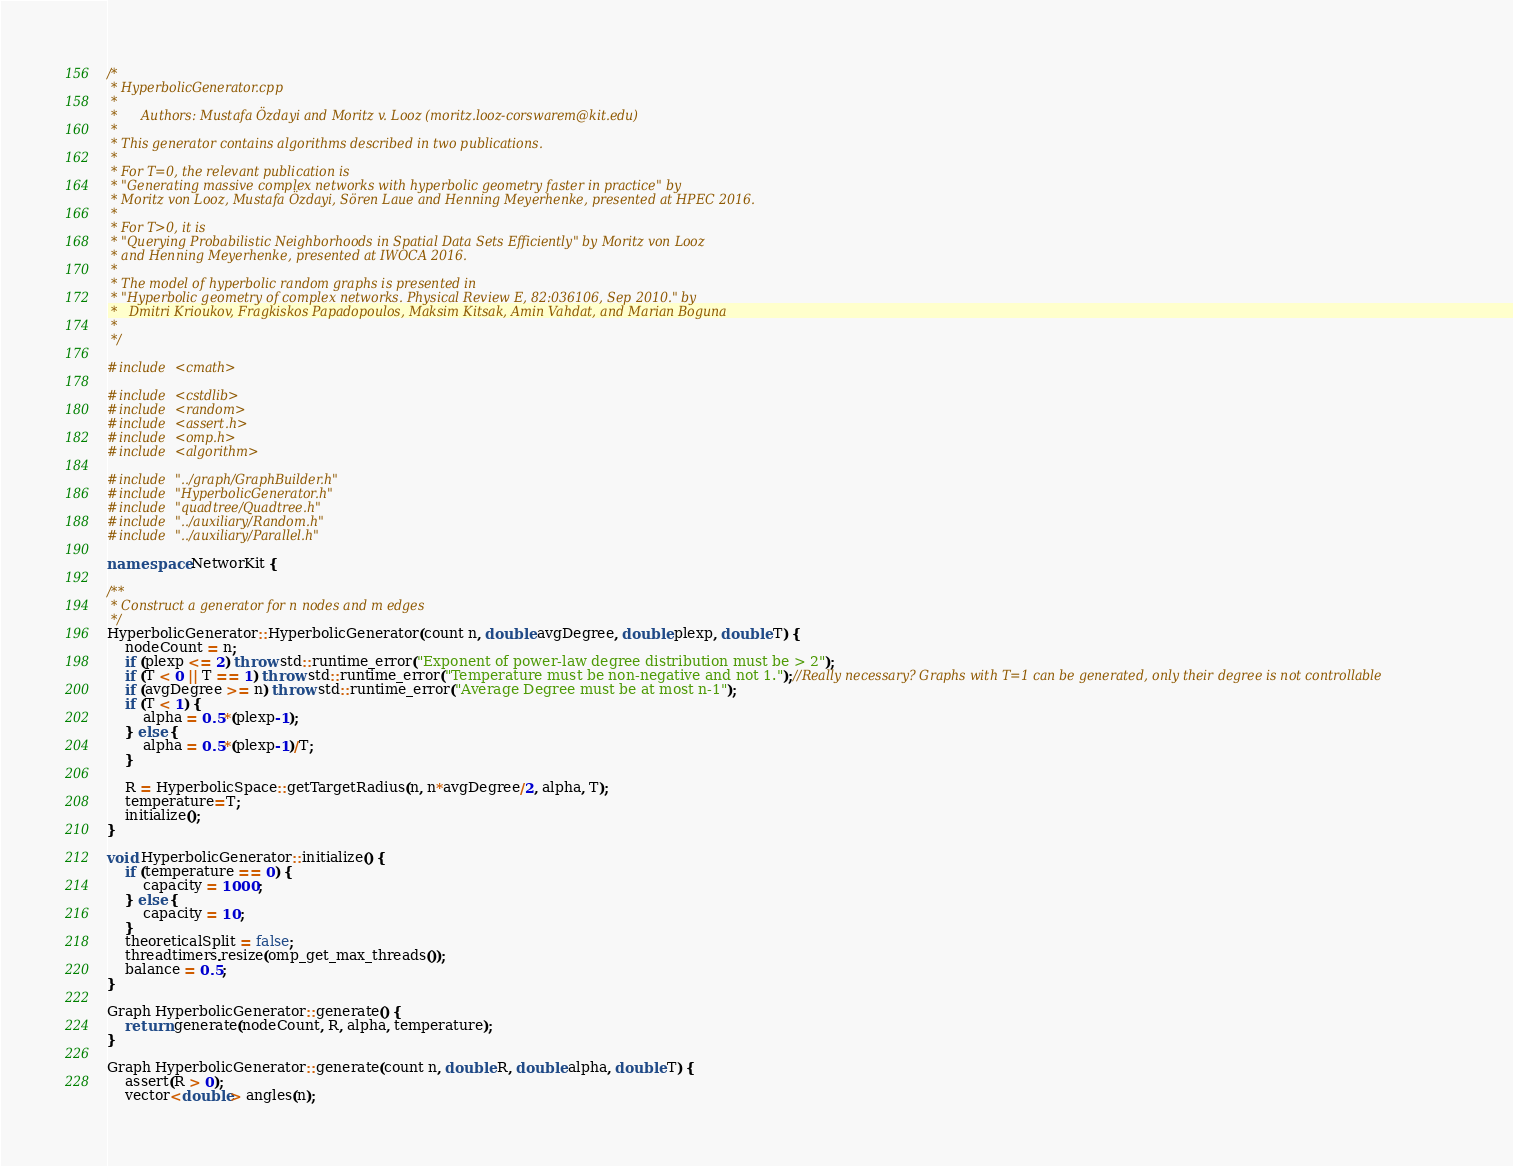<code> <loc_0><loc_0><loc_500><loc_500><_C++_>/*
 * HyperbolicGenerator.cpp
 *
 *      Authors: Mustafa Özdayi and Moritz v. Looz (moritz.looz-corswarem@kit.edu)
 *
 * This generator contains algorithms described in two publications.
 *
 * For T=0, the relevant publication is
 * "Generating massive complex networks with hyperbolic geometry faster in practice" by
 * Moritz von Looz, Mustafa Özdayi, Sören Laue and Henning Meyerhenke, presented at HPEC 2016.
 *
 * For T>0, it is
 * "Querying Probabilistic Neighborhoods in Spatial Data Sets Efficiently" by Moritz von Looz
 * and Henning Meyerhenke, presented at IWOCA 2016.
 *
 * The model of hyperbolic random graphs is presented in
 * "Hyperbolic geometry of complex networks. Physical Review E, 82:036106, Sep 2010." by
 *   Dmitri Krioukov, Fragkiskos Papadopoulos, Maksim Kitsak, Amin Vahdat, and Marian Boguna
 *
 */

#include <cmath>

#include <cstdlib>
#include <random>
#include <assert.h>
#include <omp.h>
#include <algorithm>

#include "../graph/GraphBuilder.h"
#include "HyperbolicGenerator.h"
#include "quadtree/Quadtree.h"
#include "../auxiliary/Random.h"
#include "../auxiliary/Parallel.h"

namespace NetworKit {

/**
 * Construct a generator for n nodes and m edges
 */
HyperbolicGenerator::HyperbolicGenerator(count n, double avgDegree, double plexp, double T) {
	nodeCount = n;
	if (plexp <= 2) throw std::runtime_error("Exponent of power-law degree distribution must be > 2");
	if (T < 0 || T == 1) throw std::runtime_error("Temperature must be non-negative and not 1.");//Really necessary? Graphs with T=1 can be generated, only their degree is not controllable
	if (avgDegree >= n) throw std::runtime_error("Average Degree must be at most n-1");
	if (T < 1) {
		alpha = 0.5*(plexp-1);
	} else {
		alpha = 0.5*(plexp-1)/T;
	}

	R = HyperbolicSpace::getTargetRadius(n, n*avgDegree/2, alpha, T);
	temperature=T;
	initialize();
}

void HyperbolicGenerator::initialize() {
	if (temperature == 0) {
		capacity = 1000;
	} else {
		capacity = 10;
	}
	theoreticalSplit = false;
	threadtimers.resize(omp_get_max_threads());
	balance = 0.5;
}

Graph HyperbolicGenerator::generate() {
	return generate(nodeCount, R, alpha, temperature);
}

Graph HyperbolicGenerator::generate(count n, double R, double alpha, double T) {
	assert(R > 0);
	vector<double> angles(n);</code> 